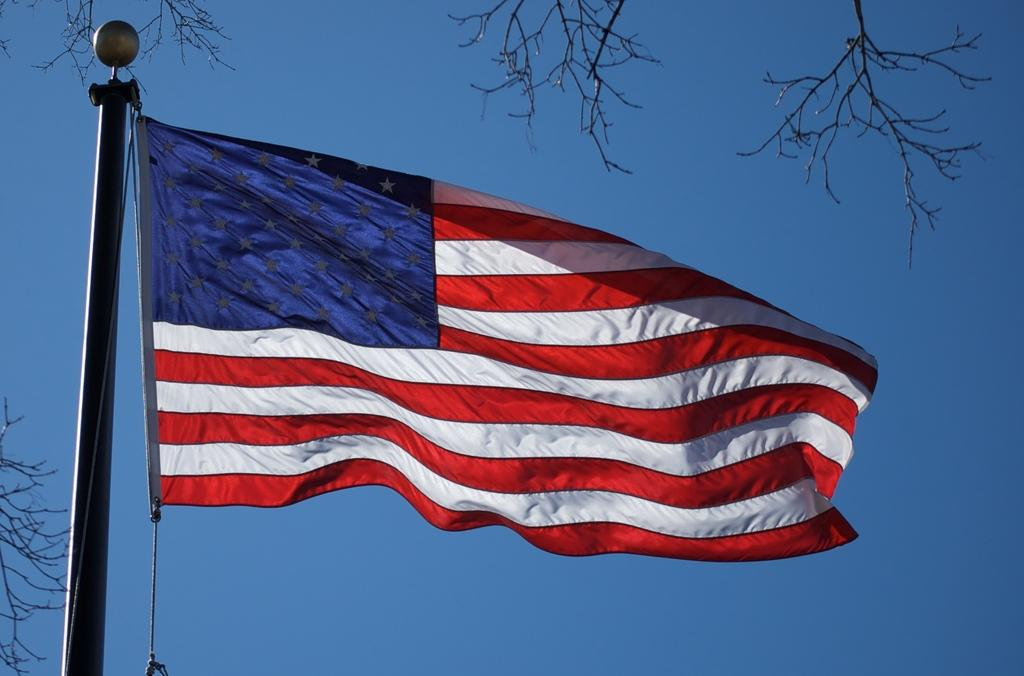What can be seen in the image that represents a country or symbol? There is a flag in the image. What colors are present on the flag? The flag has blue, white, and red colors. How is the flag displayed in the image? The flag is attached to a pole. What type of vegetation can be seen in the background of the image? There are dried trees in the background of the image. What is the color of the sky in the image? The sky is blue in the image. Can you see any goldfish swimming in the image? There are no goldfish present in the image. Is there any magic happening in the image? There is no magic depicted in the image. 